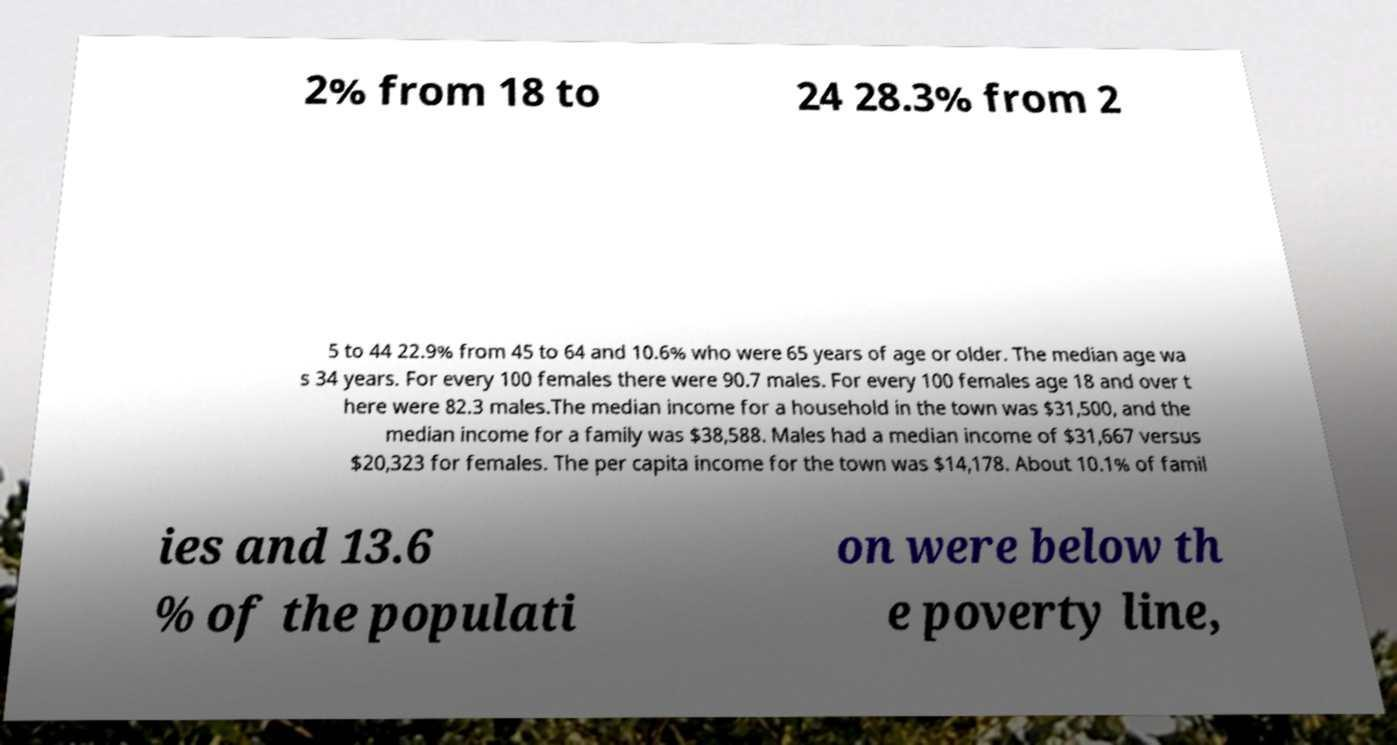Please identify and transcribe the text found in this image. 2% from 18 to 24 28.3% from 2 5 to 44 22.9% from 45 to 64 and 10.6% who were 65 years of age or older. The median age wa s 34 years. For every 100 females there were 90.7 males. For every 100 females age 18 and over t here were 82.3 males.The median income for a household in the town was $31,500, and the median income for a family was $38,588. Males had a median income of $31,667 versus $20,323 for females. The per capita income for the town was $14,178. About 10.1% of famil ies and 13.6 % of the populati on were below th e poverty line, 